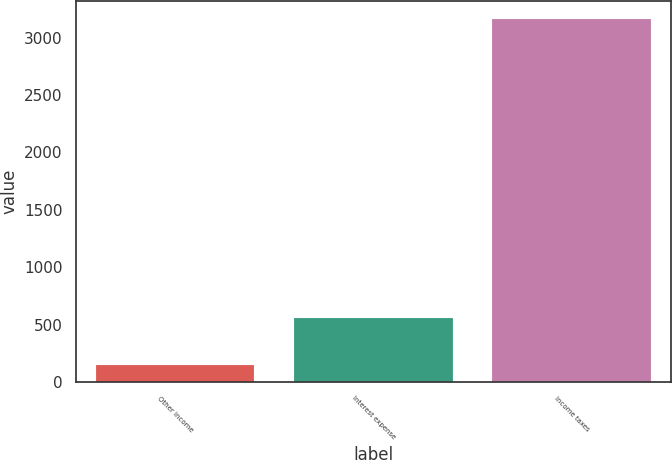<chart> <loc_0><loc_0><loc_500><loc_500><bar_chart><fcel>Other income<fcel>Interest expense<fcel>Income taxes<nl><fcel>151<fcel>561<fcel>3163<nl></chart> 